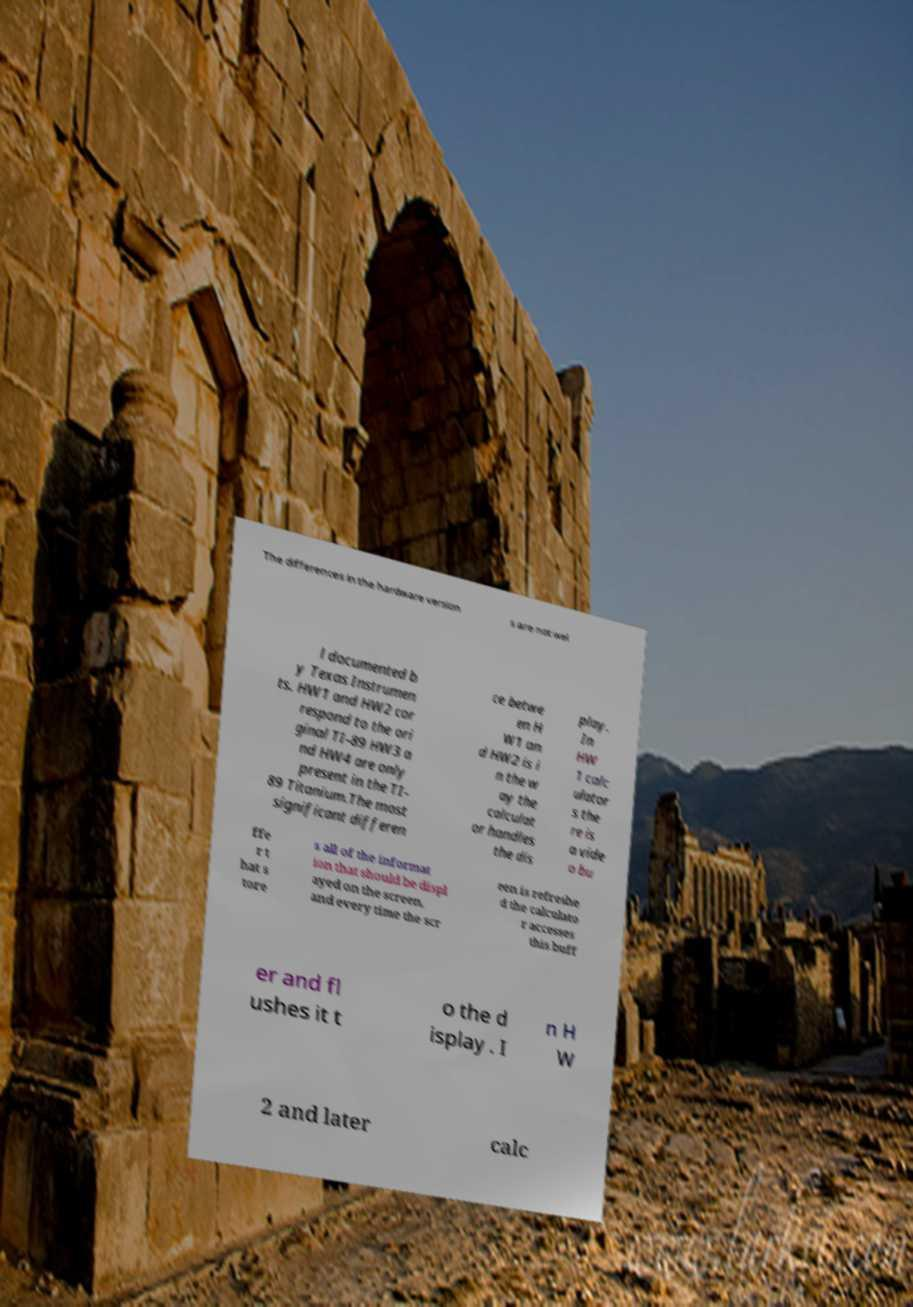Can you read and provide the text displayed in the image?This photo seems to have some interesting text. Can you extract and type it out for me? The differences in the hardware version s are not wel l documented b y Texas Instrumen ts. HW1 and HW2 cor respond to the ori ginal TI-89 HW3 a nd HW4 are only present in the TI- 89 Titanium.The most significant differen ce betwe en H W1 an d HW2 is i n the w ay the calculat or handles the dis play. In HW 1 calc ulator s the re is a vide o bu ffe r t hat s tore s all of the informat ion that should be displ ayed on the screen, and every time the scr een is refreshe d the calculato r accesses this buff er and fl ushes it t o the d isplay . I n H W 2 and later calc 